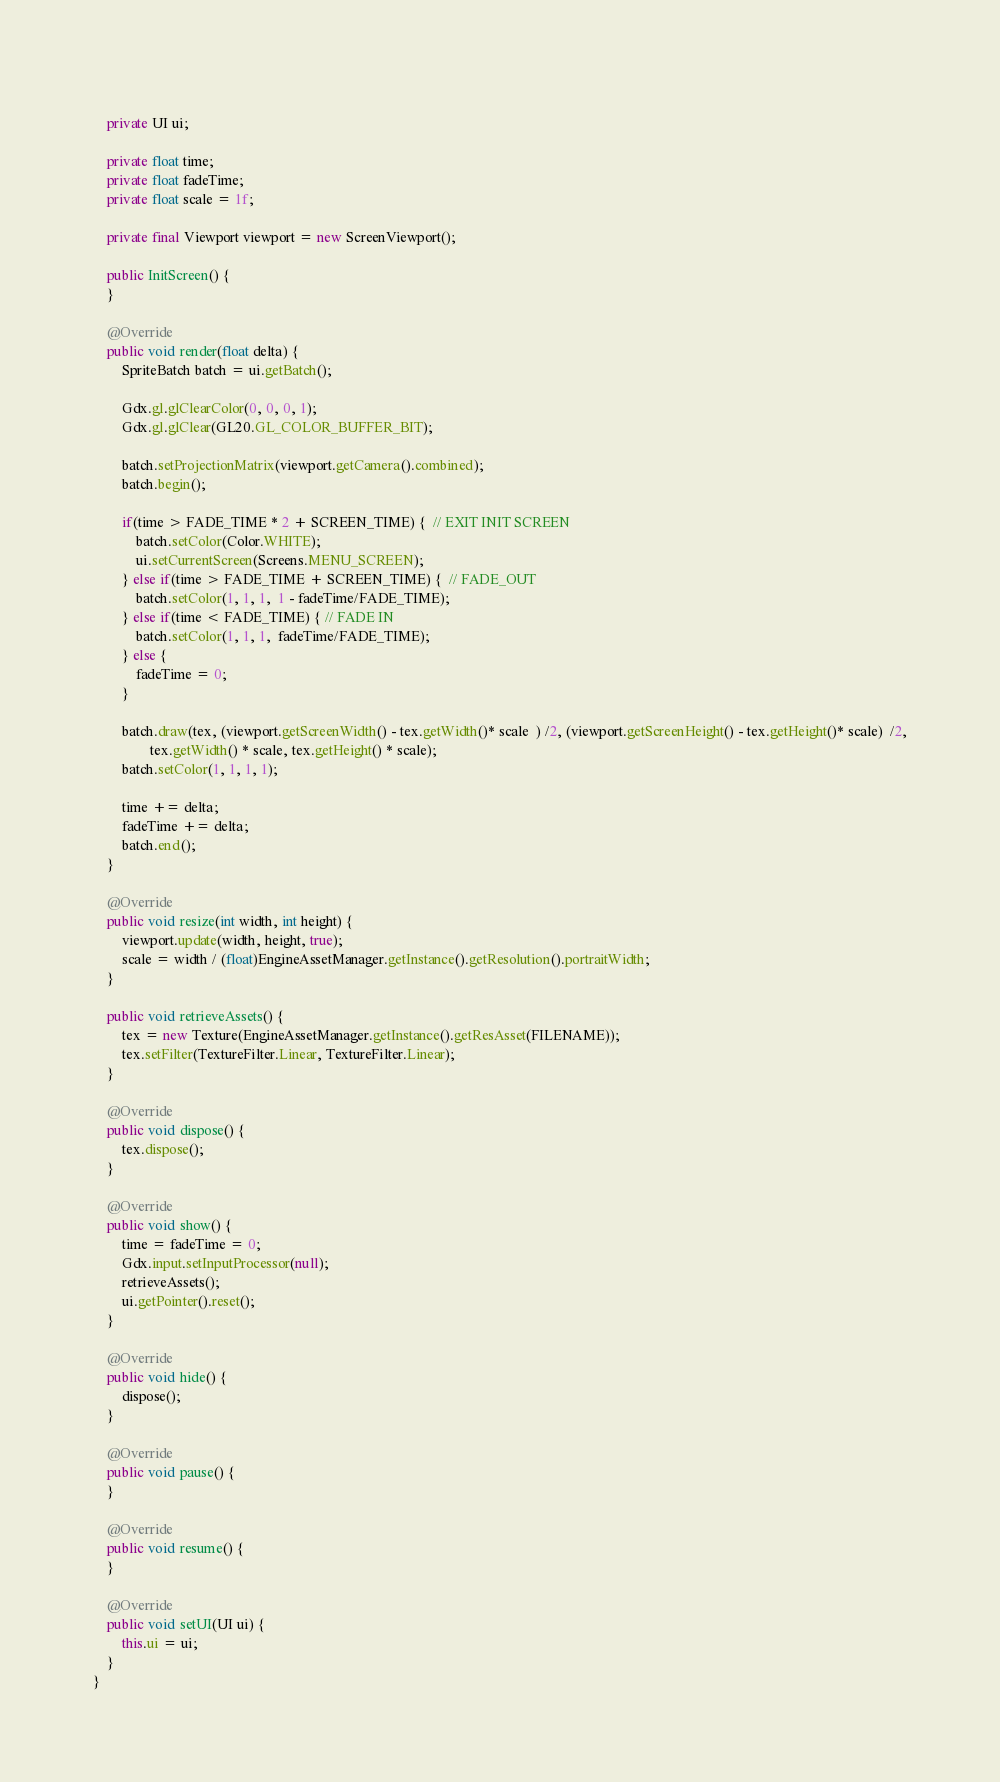<code> <loc_0><loc_0><loc_500><loc_500><_Java_>	
	private UI ui;
	
	private float time;
	private float fadeTime;
	private float scale = 1f;
	
	private final Viewport viewport = new ScreenViewport();
	
	public InitScreen() {
	}

	@Override
	public void render(float delta) {
		SpriteBatch batch = ui.getBatch();
		
		Gdx.gl.glClearColor(0, 0, 0, 1);			
		Gdx.gl.glClear(GL20.GL_COLOR_BUFFER_BIT);

		batch.setProjectionMatrix(viewport.getCamera().combined);
		batch.begin();	
		
		if(time > FADE_TIME * 2 + SCREEN_TIME) {  // EXIT INIT SCREEN
			batch.setColor(Color.WHITE);
			ui.setCurrentScreen(Screens.MENU_SCREEN);
		} else if(time > FADE_TIME + SCREEN_TIME) {  // FADE_OUT
			batch.setColor(1, 1, 1,  1 - fadeTime/FADE_TIME);			
		} else if(time < FADE_TIME) { // FADE IN
			batch.setColor(1, 1, 1,  fadeTime/FADE_TIME);	
		} else {
			fadeTime = 0;
		}		
		
		batch.draw(tex, (viewport.getScreenWidth() - tex.getWidth()* scale  ) /2, (viewport.getScreenHeight() - tex.getHeight()* scale)  /2,
				tex.getWidth() * scale, tex.getHeight() * scale);
		batch.setColor(1, 1, 1, 1);
	
		time += delta;
		fadeTime += delta;
		batch.end();
	}

	@Override
	public void resize(int width, int height) {	
		viewport.update(width, height, true);
		scale = width / (float)EngineAssetManager.getInstance().getResolution().portraitWidth;
	}

	public void retrieveAssets() {
		tex = new Texture(EngineAssetManager.getInstance().getResAsset(FILENAME));
		tex.setFilter(TextureFilter.Linear, TextureFilter.Linear);	
	}

	@Override
	public void dispose() {
		tex.dispose();
	}

	@Override
	public void show() {
		time = fadeTime = 0;
		Gdx.input.setInputProcessor(null);
		retrieveAssets();
		ui.getPointer().reset();
	}

	@Override
	public void hide() {
		dispose();
	}

	@Override
	public void pause() {
	}

	@Override
	public void resume() {
	}

	@Override
	public void setUI(UI ui) {
		this.ui = ui;
	}
}
</code> 